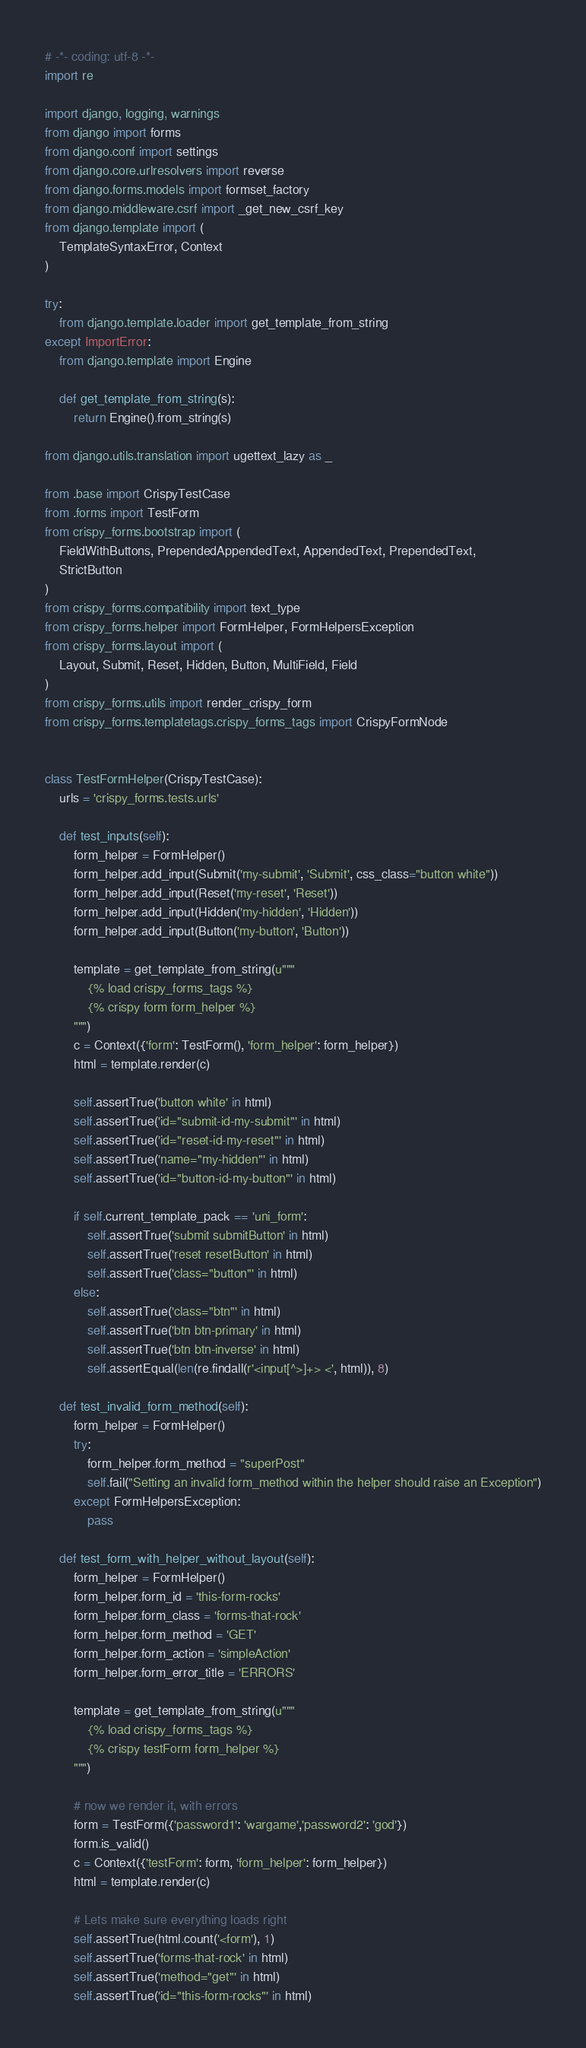<code> <loc_0><loc_0><loc_500><loc_500><_Python_># -*- coding: utf-8 -*-
import re

import django, logging, warnings
from django import forms
from django.conf import settings
from django.core.urlresolvers import reverse
from django.forms.models import formset_factory
from django.middleware.csrf import _get_new_csrf_key
from django.template import (
    TemplateSyntaxError, Context
)

try:
    from django.template.loader import get_template_from_string
except ImportError:
    from django.template import Engine

    def get_template_from_string(s):
        return Engine().from_string(s)

from django.utils.translation import ugettext_lazy as _

from .base import CrispyTestCase
from .forms import TestForm
from crispy_forms.bootstrap import (
    FieldWithButtons, PrependedAppendedText, AppendedText, PrependedText,
    StrictButton
)
from crispy_forms.compatibility import text_type
from crispy_forms.helper import FormHelper, FormHelpersException
from crispy_forms.layout import (
    Layout, Submit, Reset, Hidden, Button, MultiField, Field
)
from crispy_forms.utils import render_crispy_form
from crispy_forms.templatetags.crispy_forms_tags import CrispyFormNode


class TestFormHelper(CrispyTestCase):
    urls = 'crispy_forms.tests.urls'

    def test_inputs(self):
        form_helper = FormHelper()
        form_helper.add_input(Submit('my-submit', 'Submit', css_class="button white"))
        form_helper.add_input(Reset('my-reset', 'Reset'))
        form_helper.add_input(Hidden('my-hidden', 'Hidden'))
        form_helper.add_input(Button('my-button', 'Button'))

        template = get_template_from_string(u"""
            {% load crispy_forms_tags %}
            {% crispy form form_helper %}
        """)
        c = Context({'form': TestForm(), 'form_helper': form_helper})
        html = template.render(c)

        self.assertTrue('button white' in html)
        self.assertTrue('id="submit-id-my-submit"' in html)
        self.assertTrue('id="reset-id-my-reset"' in html)
        self.assertTrue('name="my-hidden"' in html)
        self.assertTrue('id="button-id-my-button"' in html)

        if self.current_template_pack == 'uni_form':
            self.assertTrue('submit submitButton' in html)
            self.assertTrue('reset resetButton' in html)
            self.assertTrue('class="button"' in html)
        else:
            self.assertTrue('class="btn"' in html)
            self.assertTrue('btn btn-primary' in html)
            self.assertTrue('btn btn-inverse' in html)
            self.assertEqual(len(re.findall(r'<input[^>]+> <', html)), 8)

    def test_invalid_form_method(self):
        form_helper = FormHelper()
        try:
            form_helper.form_method = "superPost"
            self.fail("Setting an invalid form_method within the helper should raise an Exception")
        except FormHelpersException:
            pass

    def test_form_with_helper_without_layout(self):
        form_helper = FormHelper()
        form_helper.form_id = 'this-form-rocks'
        form_helper.form_class = 'forms-that-rock'
        form_helper.form_method = 'GET'
        form_helper.form_action = 'simpleAction'
        form_helper.form_error_title = 'ERRORS'

        template = get_template_from_string(u"""
            {% load crispy_forms_tags %}
            {% crispy testForm form_helper %}
        """)

        # now we render it, with errors
        form = TestForm({'password1': 'wargame','password2': 'god'})
        form.is_valid()
        c = Context({'testForm': form, 'form_helper': form_helper})
        html = template.render(c)

        # Lets make sure everything loads right
        self.assertTrue(html.count('<form'), 1)
        self.assertTrue('forms-that-rock' in html)
        self.assertTrue('method="get"' in html)
        self.assertTrue('id="this-form-rocks"' in html)</code> 